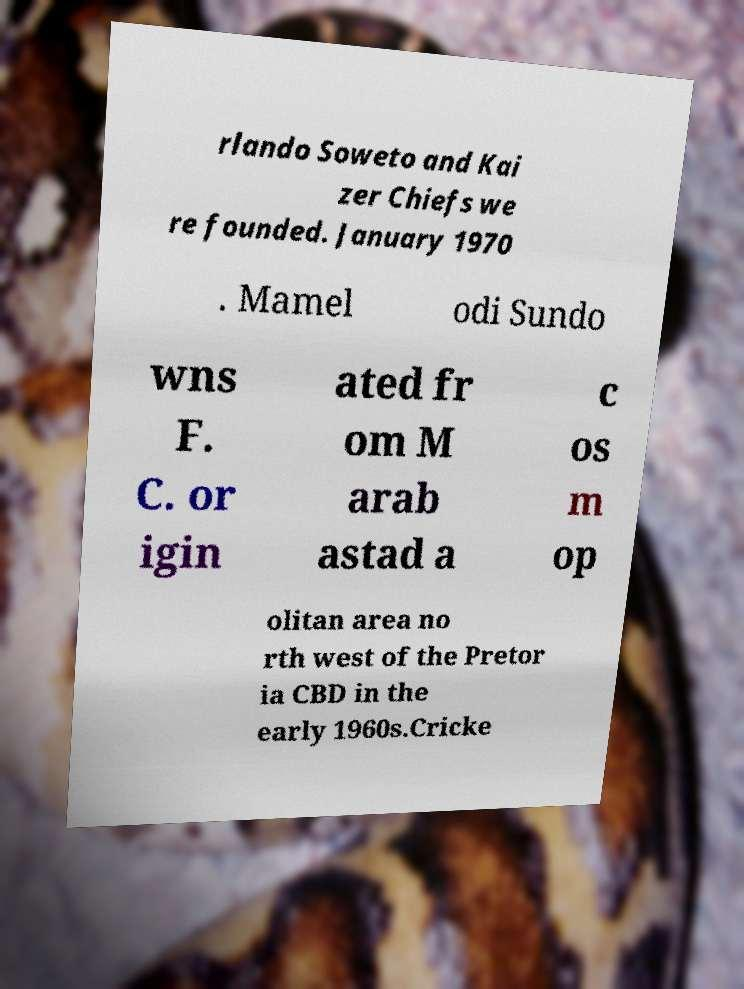Please identify and transcribe the text found in this image. rlando Soweto and Kai zer Chiefs we re founded. January 1970 . Mamel odi Sundo wns F. C. or igin ated fr om M arab astad a c os m op olitan area no rth west of the Pretor ia CBD in the early 1960s.Cricke 